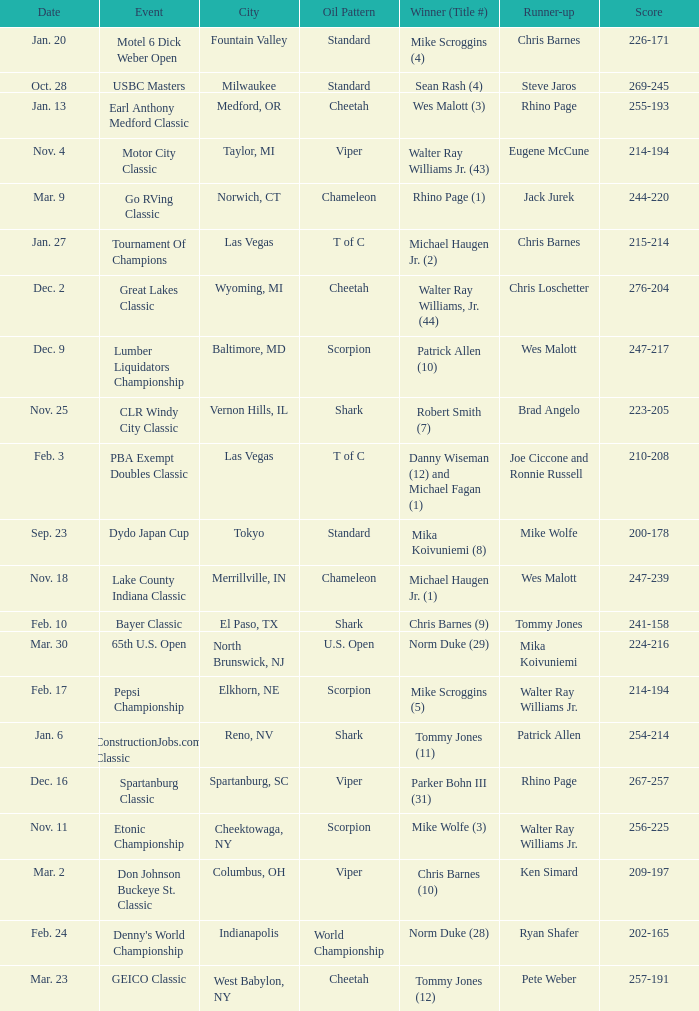Name the Event which has a Score of 209-197? Don Johnson Buckeye St. Classic. 